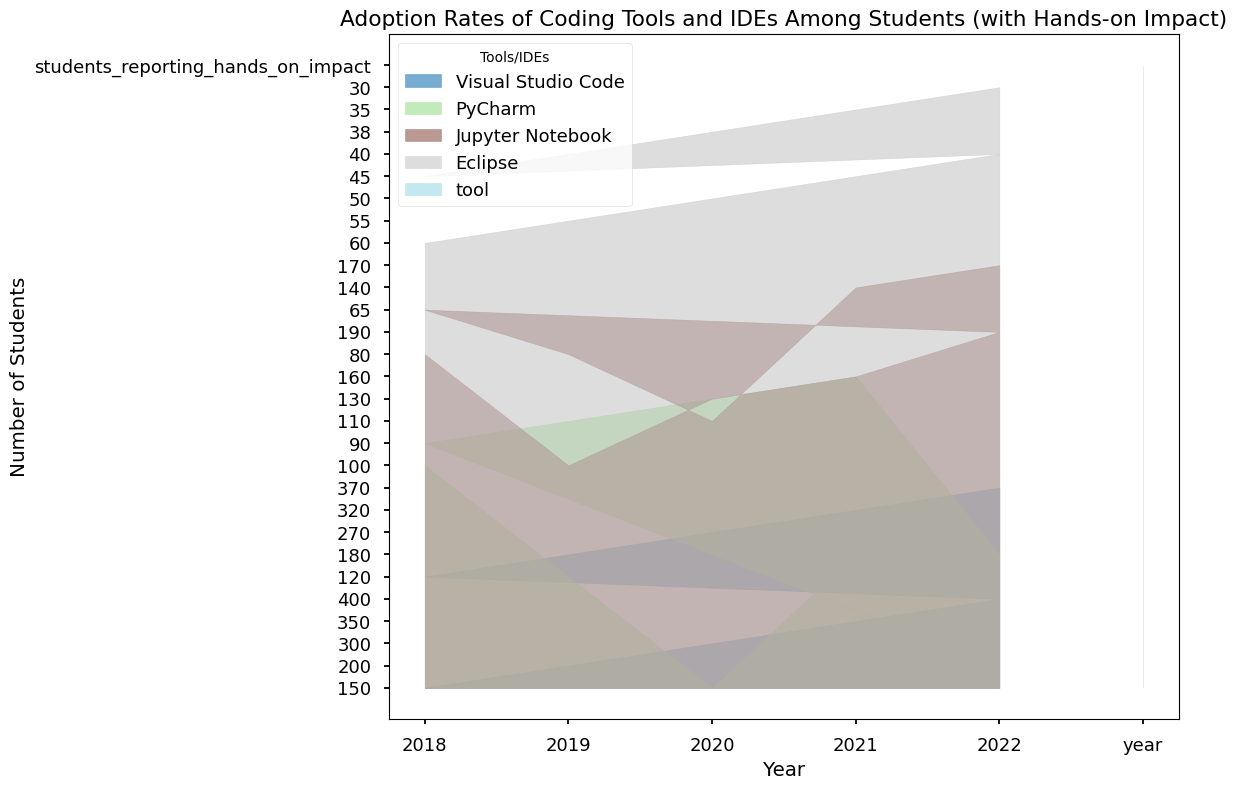What is the trend in the number of students using Visual Studio Code from 2018 to 2022? Visual Studio Code shows a consistent increase in the number of students using it each year from 2018 to 2022. The numbers rise from 150 in 2018, to 200 in 2019, to 300 in 2020, to 350 in 2021, and finally to 400 in 2022. This indicates a strong upward trend.
Answer: Upward trend How does the adoption rate of PyCharm compare to that of Eclipse in 2022? In 2022, the adoption rate of PyCharm is significantly higher than that of Eclipse. PyCharm has 200 students using it, while Eclipse only has 40 students. This shows that PyCharm is markedly more popular.
Answer: PyCharm is significantly higher Between 2018 and 2022, which tool saw the largest increase in the number of students reporting hands-on impact? Visual Studio Code saw the largest increase in the number of students reporting hands-on impact, rising from 120 in 2018 to 370 in 2022. The increase is 370 - 120 = 250 students.
Answer: Visual Studio Code What is the average number of students using Jupyter Notebook across all the years presented? To find the average, sum the number of students using Jupyter Notebook in each year: 80 + 100 + 130 + 160 + 190 = 660. Divide by the number of years (5): 660 / 5 = 132.
Answer: 132 Is there a year where the number of students using PyCharm decreased? No, there is no year where the number of students using PyCharm decreased. There is a consistent increase in the number of students year over year.
Answer: No Which tool had the least fluctuation in the number of students using it from 2018 to 2022? Eclipse had the least fluctuation. The number of students using it decreased gradually from 60 in 2018 to 40 in 2022, showing a steadier trend compared to other tools.
Answer: Eclipse In which year did Jupyter Notebook see the highest increase in student adoption compared to the previous year? The highest increase in student adoption for Jupyter Notebook occurred in 2021, where the number of students increased from 130 in 2020 to 160 in 2021, resulting in an increase of 30 students.
Answer: 2021 How does the number of students reporting the impact of hands-on practice compare between Visual Studio Code and Jupyter Notebook in 2019? In 2019, the number of students reporting the impact of hands-on practice for Visual Studio Code is 180, while for Jupyter Notebook it is 80. Hence, Visual Studio Code has 100 more students reporting hands-on practice impact compared to Jupyter Notebook.
Answer: 100 more for Visual Studio Code What is the total number of students using all tools in 2020? Sum the number of students using each tool in 2020: Visual Studio Code (300) + PyCharm (150) + Jupyter Notebook (130) + Eclipse (50) = 630.
Answer: 630 